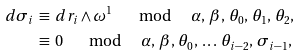<formula> <loc_0><loc_0><loc_500><loc_500>d \sigma _ { i } \, & \equiv \, d r _ { i } \wedge \omega ^ { 1 } \quad \mod \quad \alpha , \, \beta , \, \theta _ { 0 } , \, \theta _ { 1 } , \, \theta _ { 2 } , \\ & \equiv \, 0 \quad \mod \quad \alpha , \, \beta , \, \theta _ { 0 } , \, \dots \, \theta _ { i - 2 } , \, \sigma _ { i - 1 } ,</formula> 